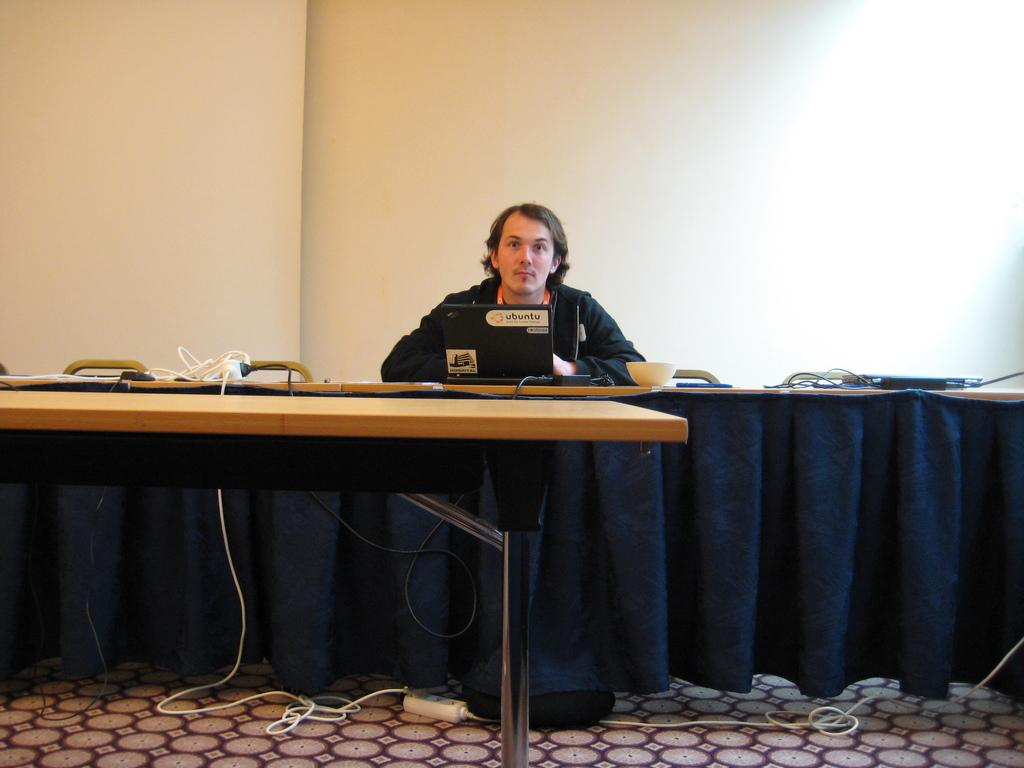What is the man in the image doing? The man is sitting on a chair in the image. What is in front of the man? The man is in front of a table. What electronic device is on the table? There is a laptop on the table. What else is on the table besides the laptop? There is a bowl and a wired object on the table. What is the wired object on the table? There is a router on the table. What can be seen in the background of the image? There is a cloth in the background of the image, and the wall is white. What type of comb is the man using to style his hair in the image? There is no comb visible in the image, and the man's hair is not being styled. What government policy is being discussed in the image? There is no discussion of government policy in the image; it is focused on the man, the table, and the objects on it. 